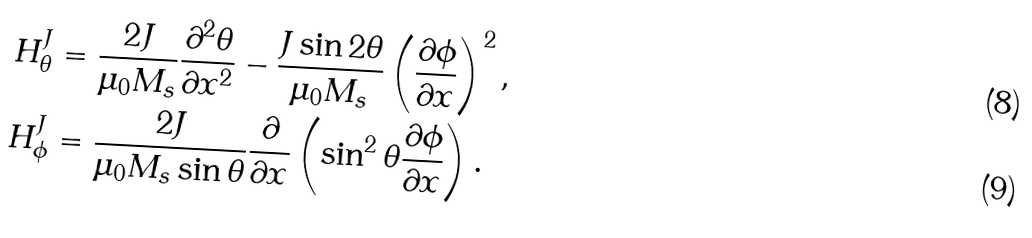Convert formula to latex. <formula><loc_0><loc_0><loc_500><loc_500>H ^ { J } _ { \theta } & = \frac { 2 J } { \mu _ { 0 } M _ { s } } \frac { \partial ^ { 2 } \theta } { \partial x ^ { 2 } } - \frac { J \sin 2 \theta } { \mu _ { 0 } M _ { s } } \left ( \frac { \partial \phi } { \partial x } \right ) ^ { 2 } , \\ H ^ { J } _ { \phi } & = \frac { 2 J } { \mu _ { 0 } M _ { s } \sin \theta } \frac { \partial } { \partial x } \left ( \sin ^ { 2 } \theta \frac { \partial \phi } { \partial x } \right ) .</formula> 